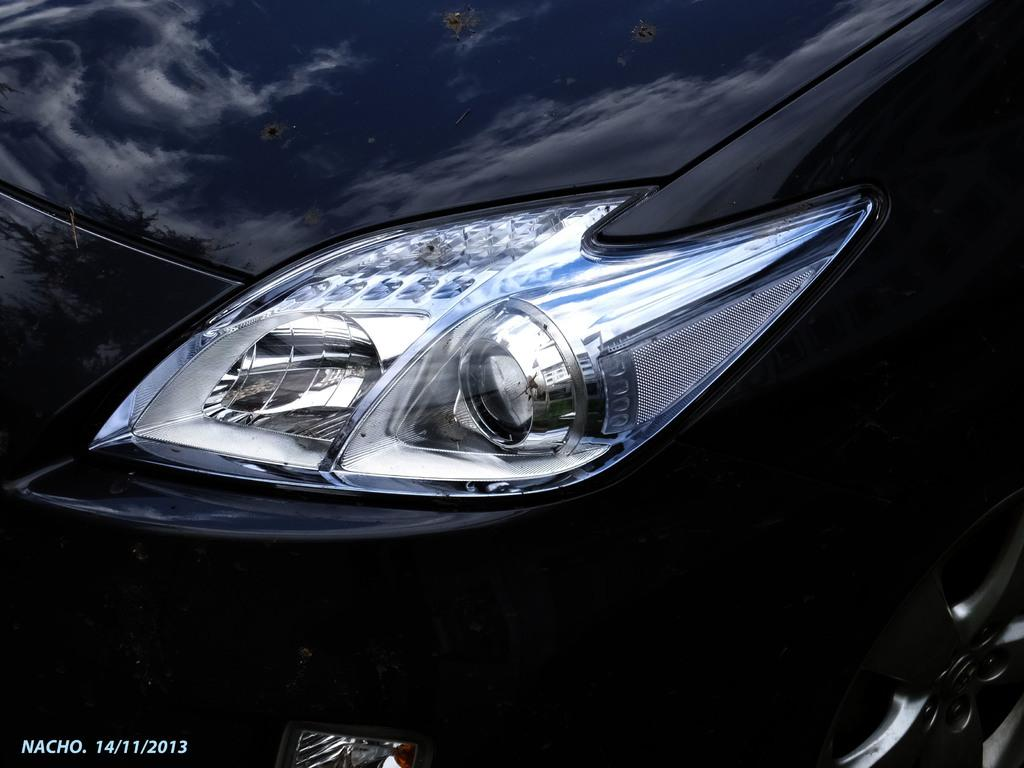What is the main subject of the image? The main subject of the image is a car. What specific feature can be seen on the car? The car has a headlight. What is the color of the car in the image? The car is black in color. What type of riddle is the car trying to solve in the image? There is no indication in the image that the car is trying to solve a riddle; it is simply a stationary object. 